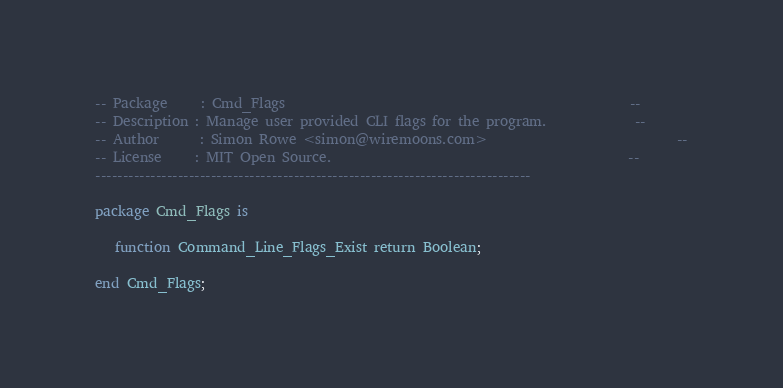<code> <loc_0><loc_0><loc_500><loc_500><_Ada_>-- Package     : Cmd_Flags                                                   --
-- Description : Manage user provided CLI flags for the program.             --
-- Author      : Simon Rowe <simon@wiremoons.com>                            --
-- License     : MIT Open Source.                                            --
-------------------------------------------------------------------------------

package Cmd_Flags is

   function Command_Line_Flags_Exist return Boolean;

end Cmd_Flags;
</code> 